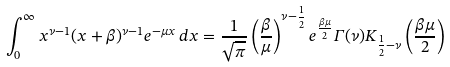Convert formula to latex. <formula><loc_0><loc_0><loc_500><loc_500>\int _ { 0 } ^ { \infty } x ^ { \nu - 1 } ( x + \beta ) ^ { \nu - 1 } e ^ { - \mu x } \, d x = \frac { 1 } { \sqrt { \pi } } \left ( \frac { \beta } { \mu } \right ) ^ { \nu - \frac { 1 } { 2 } } e ^ { \frac { \beta \mu } { 2 } } \varGamma ( \nu ) K _ { \frac { 1 } { 2 } - \nu } \left ( \frac { \beta \mu } { 2 } \right )</formula> 